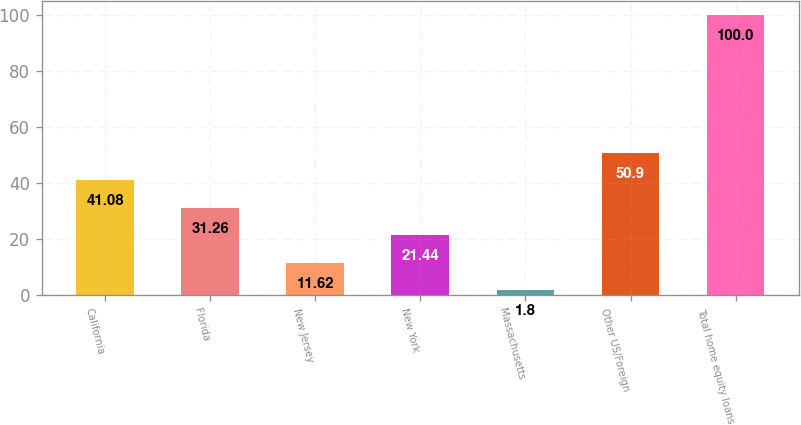Convert chart. <chart><loc_0><loc_0><loc_500><loc_500><bar_chart><fcel>California<fcel>Florida<fcel>New Jersey<fcel>New York<fcel>Massachusetts<fcel>Other US/Foreign<fcel>Total home equity loans<nl><fcel>41.08<fcel>31.26<fcel>11.62<fcel>21.44<fcel>1.8<fcel>50.9<fcel>100<nl></chart> 